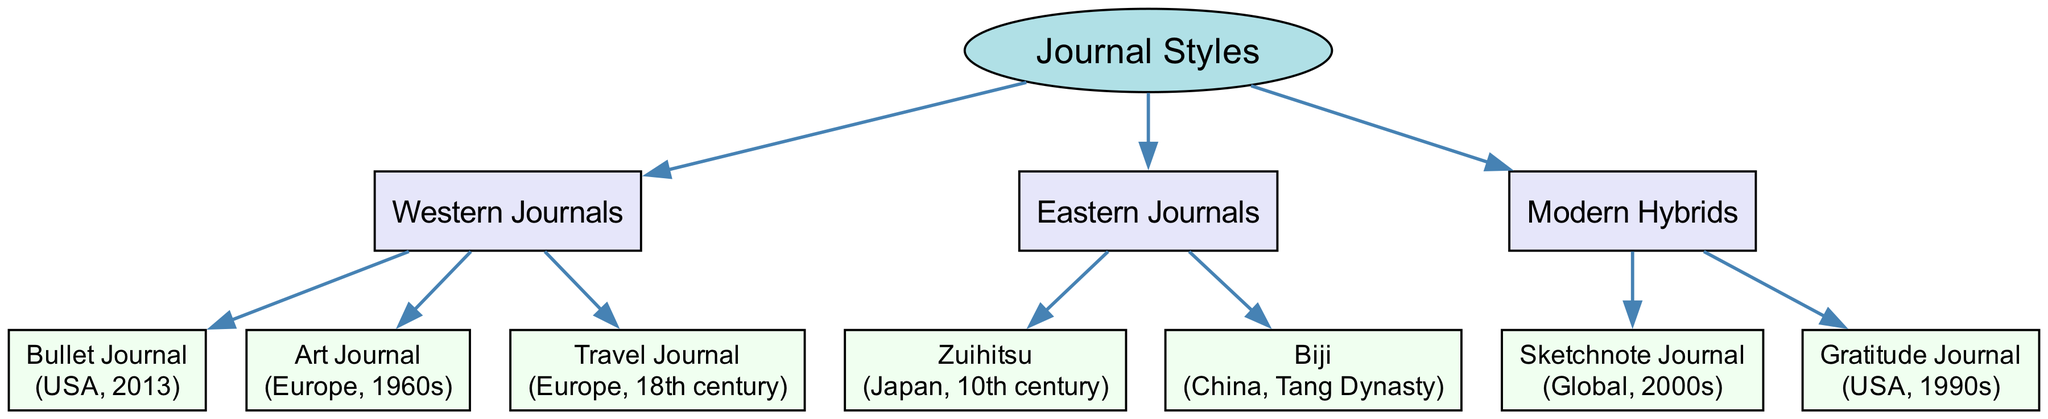What is the root node of the diagram? The root node is specified in the diagram data as "Journal Styles".
Answer: Journal Styles How many main categories are there under Western Journals? Western Journals contains three styles: Bullet Journal, Art Journal, and Travel Journal. Therefore, counting these gives us a total of three.
Answer: 3 What is the origin of the Bullet Journal? The Bullet Journal's origin, as stated in the diagram, is the USA in 2013.
Answer: USA, 2013 Which journal style has its origins in the 10th century? The diagram lists Zuihitsu as originating from Japan in the 10th century, making it the style that matches this origin.
Answer: Zuihitsu How many styles are categorized under Eastern Journals? Eastern Journals includes two styles: Zuihitsu and Biji. Thus, the total count of styles here is two.
Answer: 2 Which journal style is a modern hybrid and originated in the 2000s? The Sketchnote Journal is the style that fits this description, as it is identified in the diagram as a modern hybrid from the 2000s.
Answer: Sketchnote Journal What is the relationship between Art Journal and Western Journals? The Art Journal is categorized as a child node under the Western Journals parent node, indicating that it is part of this classification of journal styles.
Answer: Child under Western Journals What is the total number of journal styles depicted in the diagram? By counting all the styles in each category—3 in Western Journals, 2 in Eastern Journals, and 2 in Modern Hybrids—we arrive at a total of 7 journal styles.
Answer: 7 Which style originated from China during the Tang Dynasty? Biji is specifically listed as having its origins in China during the Tang Dynasty, making this the correct answer to the question.
Answer: Biji 